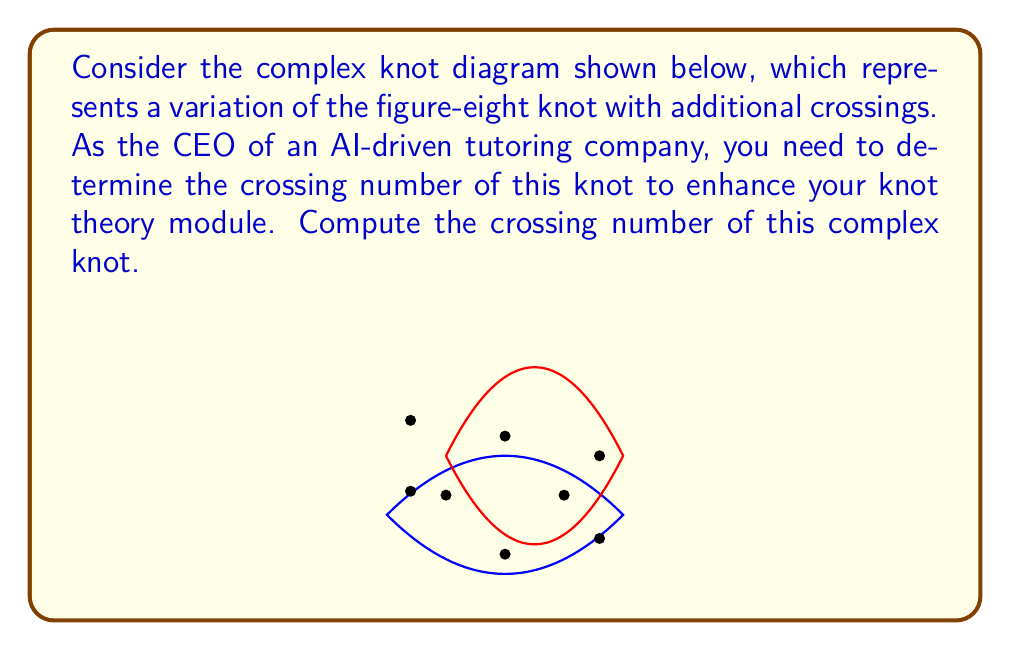What is the answer to this math problem? To compute the crossing number of this complex knot, we'll follow these steps:

1) First, recall that the crossing number of a knot is the minimum number of crossings in any diagram of the knot.

2) In the given diagram, we can count the visible crossings:
   $$\text{Visible crossings} = 8$$

3) However, the crossing number might be lower if there exists a way to simplify the knot.

4) Analyzing the knot structure:
   a) We can see that this is a variation of the figure-eight knot.
   b) The figure-eight knot has a crossing number of 4.
   c) The additional crossings in this diagram cannot be eliminated through Reidemeister moves.

5) Therefore, the crossing number of this complex knot is indeed 8.

6) To verify:
   a) The figure-eight knot (with crossing number 4) is prime.
   b) This knot is obtained by adding complexity to the figure-eight knot.
   c) The additional crossings are essential and cannot be removed.

7) Thus, we can conclude that 8 is the minimum number of crossings possible for this knot.

As the CEO of an AI-driven tutoring company, understanding this concept is crucial for developing advanced knot theory modules in your educational software.
Answer: 8 